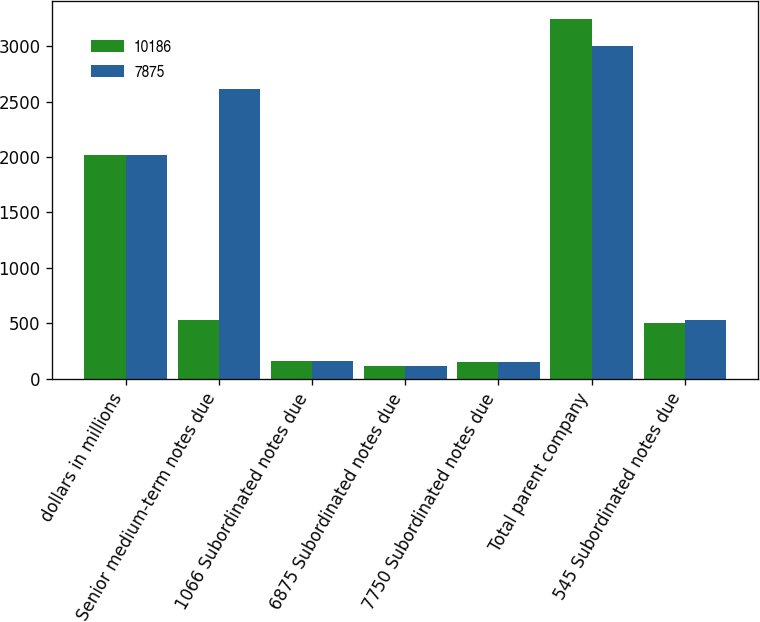<chart> <loc_0><loc_0><loc_500><loc_500><stacked_bar_chart><ecel><fcel>dollars in millions<fcel>Senior medium-term notes due<fcel>1066 Subordinated notes due<fcel>6875 Subordinated notes due<fcel>7750 Subordinated notes due<fcel>Total parent company<fcel>545 Subordinated notes due<nl><fcel>10186<fcel>2015<fcel>524<fcel>162<fcel>114<fcel>147<fcel>3242<fcel>503<nl><fcel>7875<fcel>2014<fcel>2611<fcel>162<fcel>113<fcel>147<fcel>2997<fcel>524<nl></chart> 